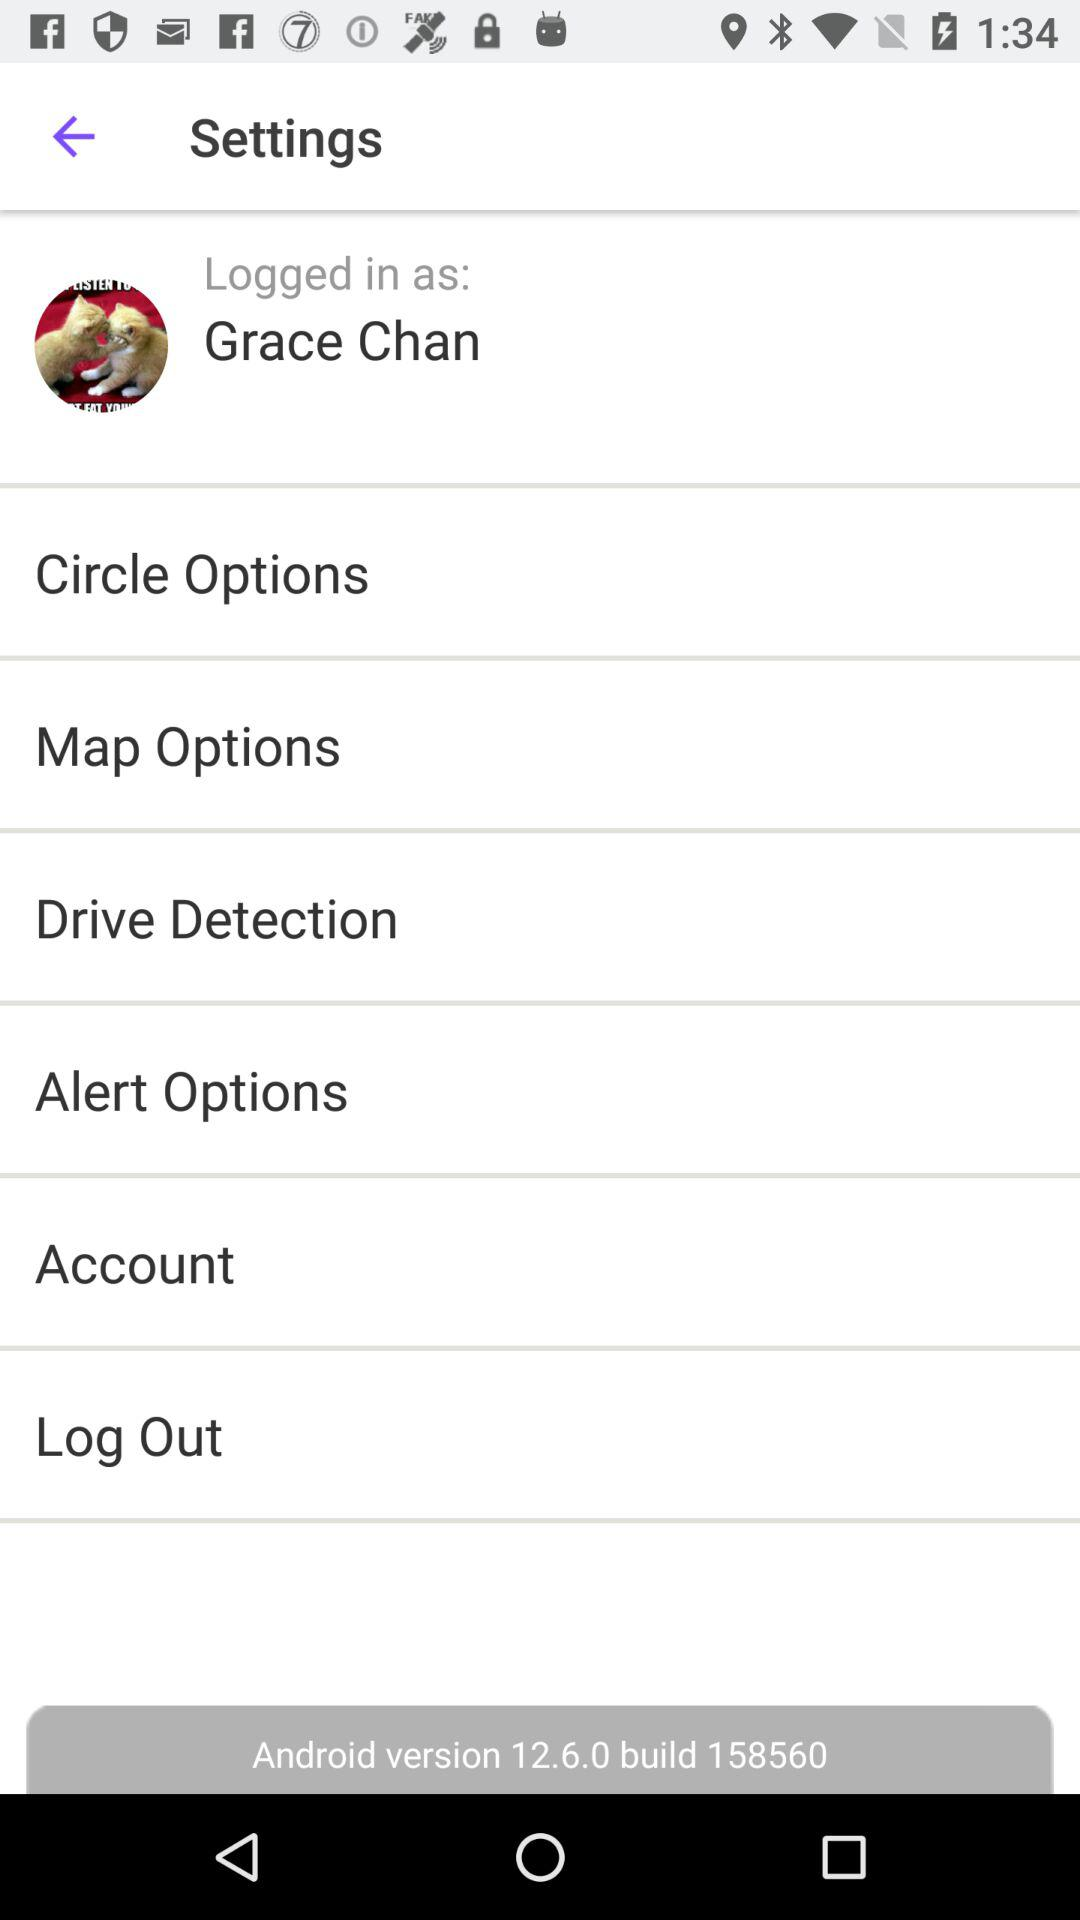What is the login name? The login name is Grace Chan. 